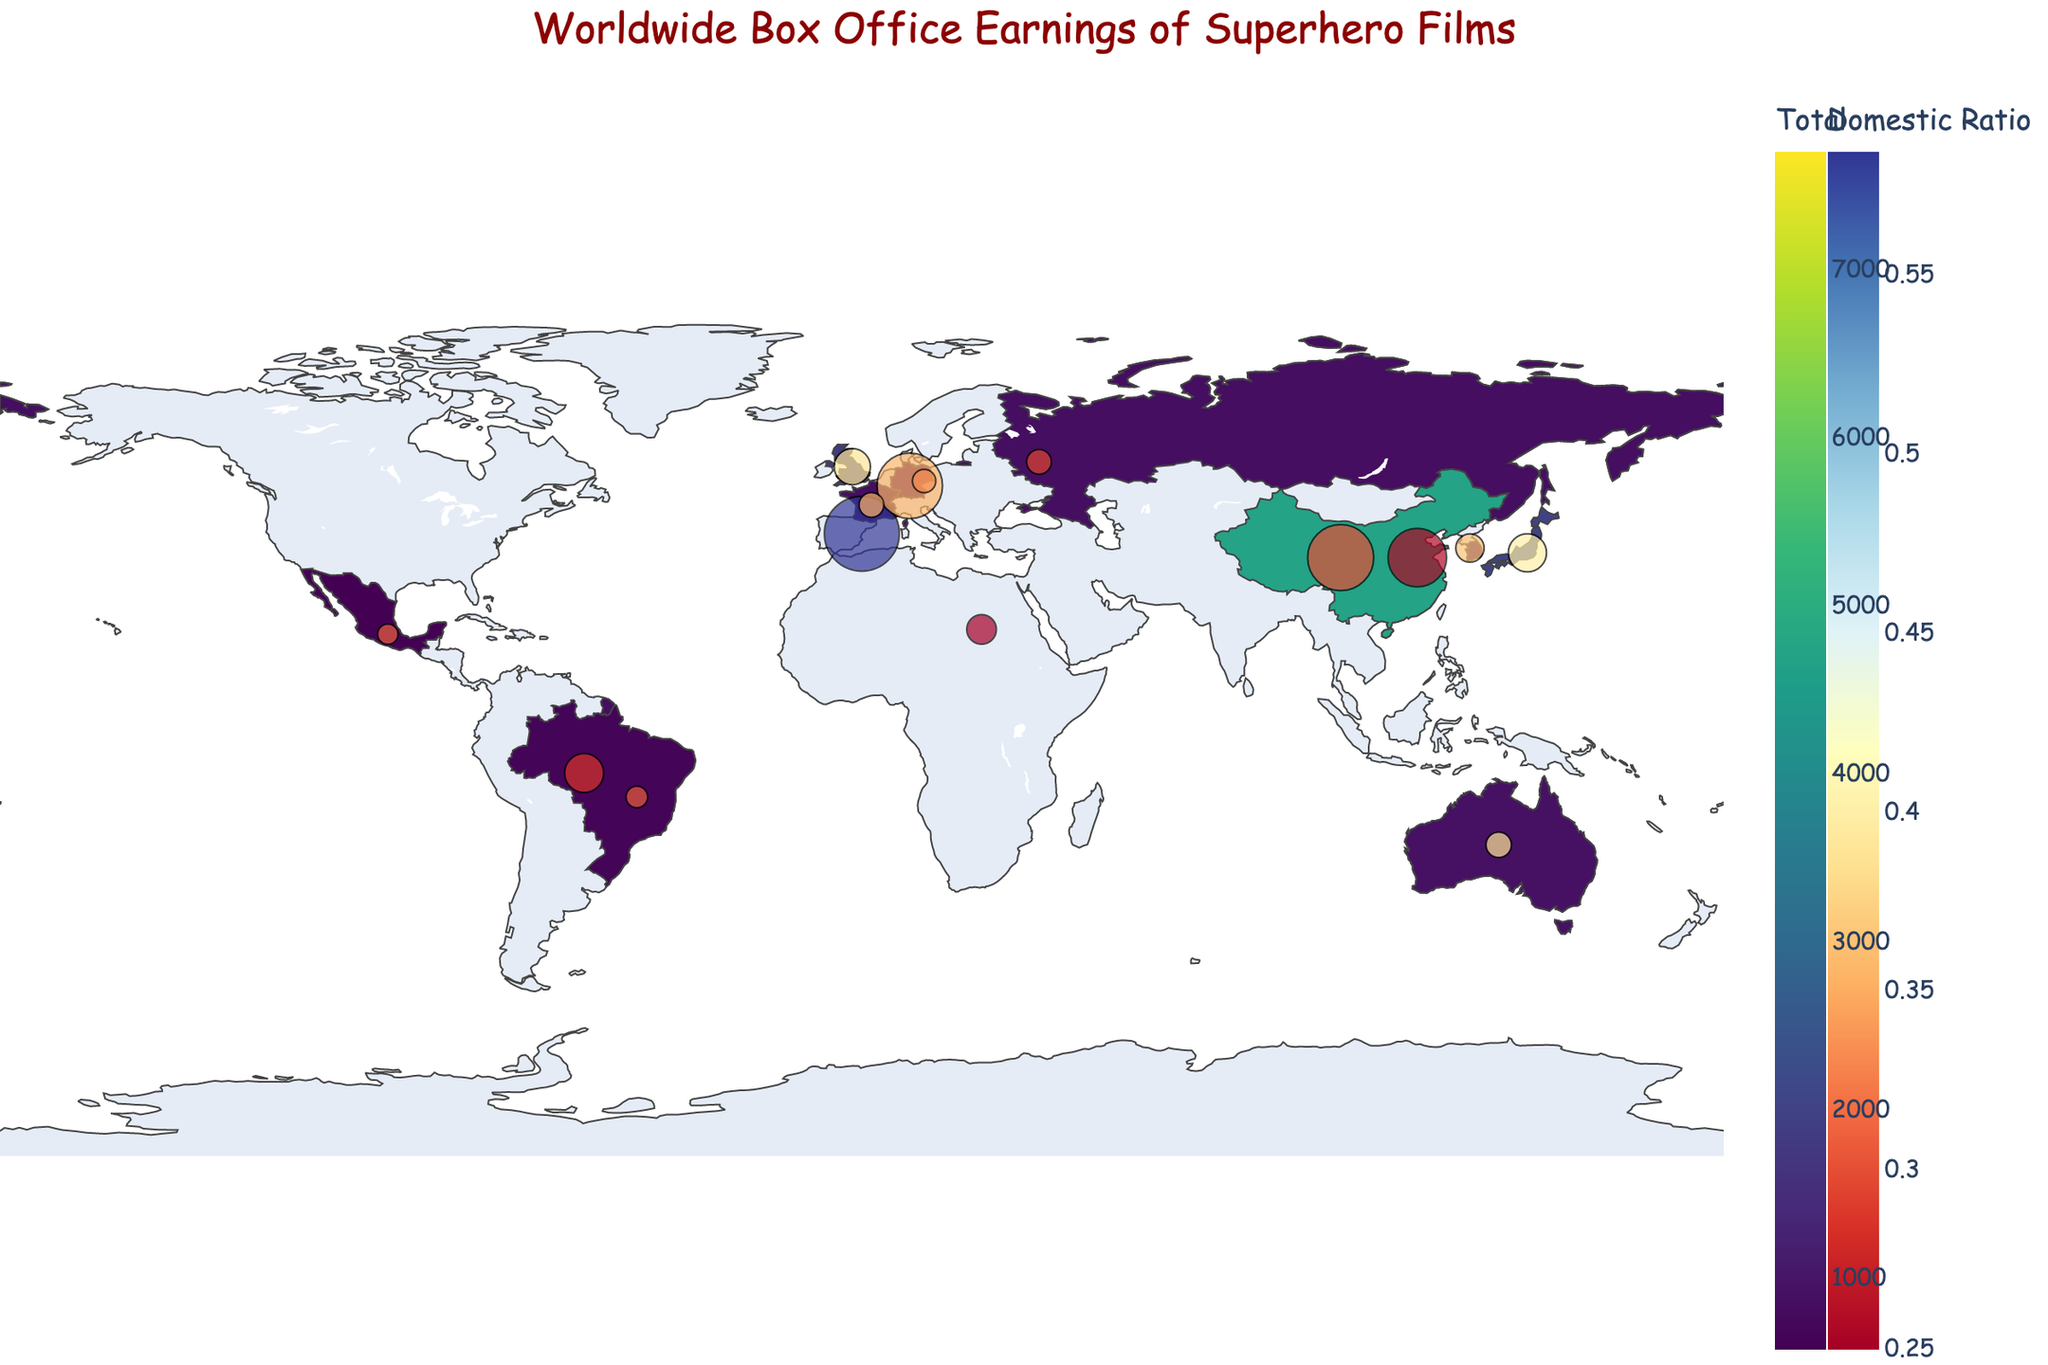What's the title of the figure? The title is typically displayed at the top of the figure. It provides an overview of what the figure is about.
Answer: Worldwide Box Office Earnings of Superhero Films How much did North America earn domestically? Locate the North America region on the map, and the hover data will show the domestic earnings. Refer to the hover information.
Answer: 4500 USD Millions Which region has the highest total box office earnings? By comparing the colors and the size of the bubbles, the region with the darkest color and the largest bubble indicates the highest earnings.
Answer: Asia-Pacific What is the ratio of domestic to international earnings for Europe? Hover over Europe to get the respective earnings. Calculate the ratio: Domestic (USD Millions) / International (USD Millions) = 2100 / 3800.
Answer: 0.55 Which region has a higher domestic earnings, China or Japan? Compare the domestic earnings from the hover data for China and Japan. Use the domestic earnings value directly.
Answer: China What is the difference in total earnings between Latin America and the Middle East & Africa? Calculate the total earnings for both regions and find the difference: (Domestic + International for Latin America) - (Domestic + International for Middle East & Africa) = (600 + 1500) - (300 + 900) = 1200.
Answer: 900 USD Millions Which region has the smallest bubble size? The bubble size is proportional to the total earnings, so find the region with the smallest total earnings. Compare the overall appearance.
Answer: Mexico What is the average international earnings for the regions listed? Sum up all international earnings and divide by the number of regions. Sum: 3200 + 3800 + 4200 + 1500 + 900 + 3500 + 1200 + 700 + 1100 + 550 + 600 + 450 + 400 + 550 + 500 = 26950. Number of regions: 15. Average: 26950 / 15.
Answer: 1797 USD Millions Which region in Europe has the highest domestic earnings? Compare the listed regions in Europe for their domestic earnings by hovering. Specifically look at the United Kingdom, France, and Germany.
Answer: United Kingdom For which region is the domestic ratio the highest? Ratio = Domestic (USD Millions) / Total. Calculate for all regions and find the highest. For example, North America has 4500 / (4500 + 3200) = 0.58. Compare all these ratios.
Answer: North America 